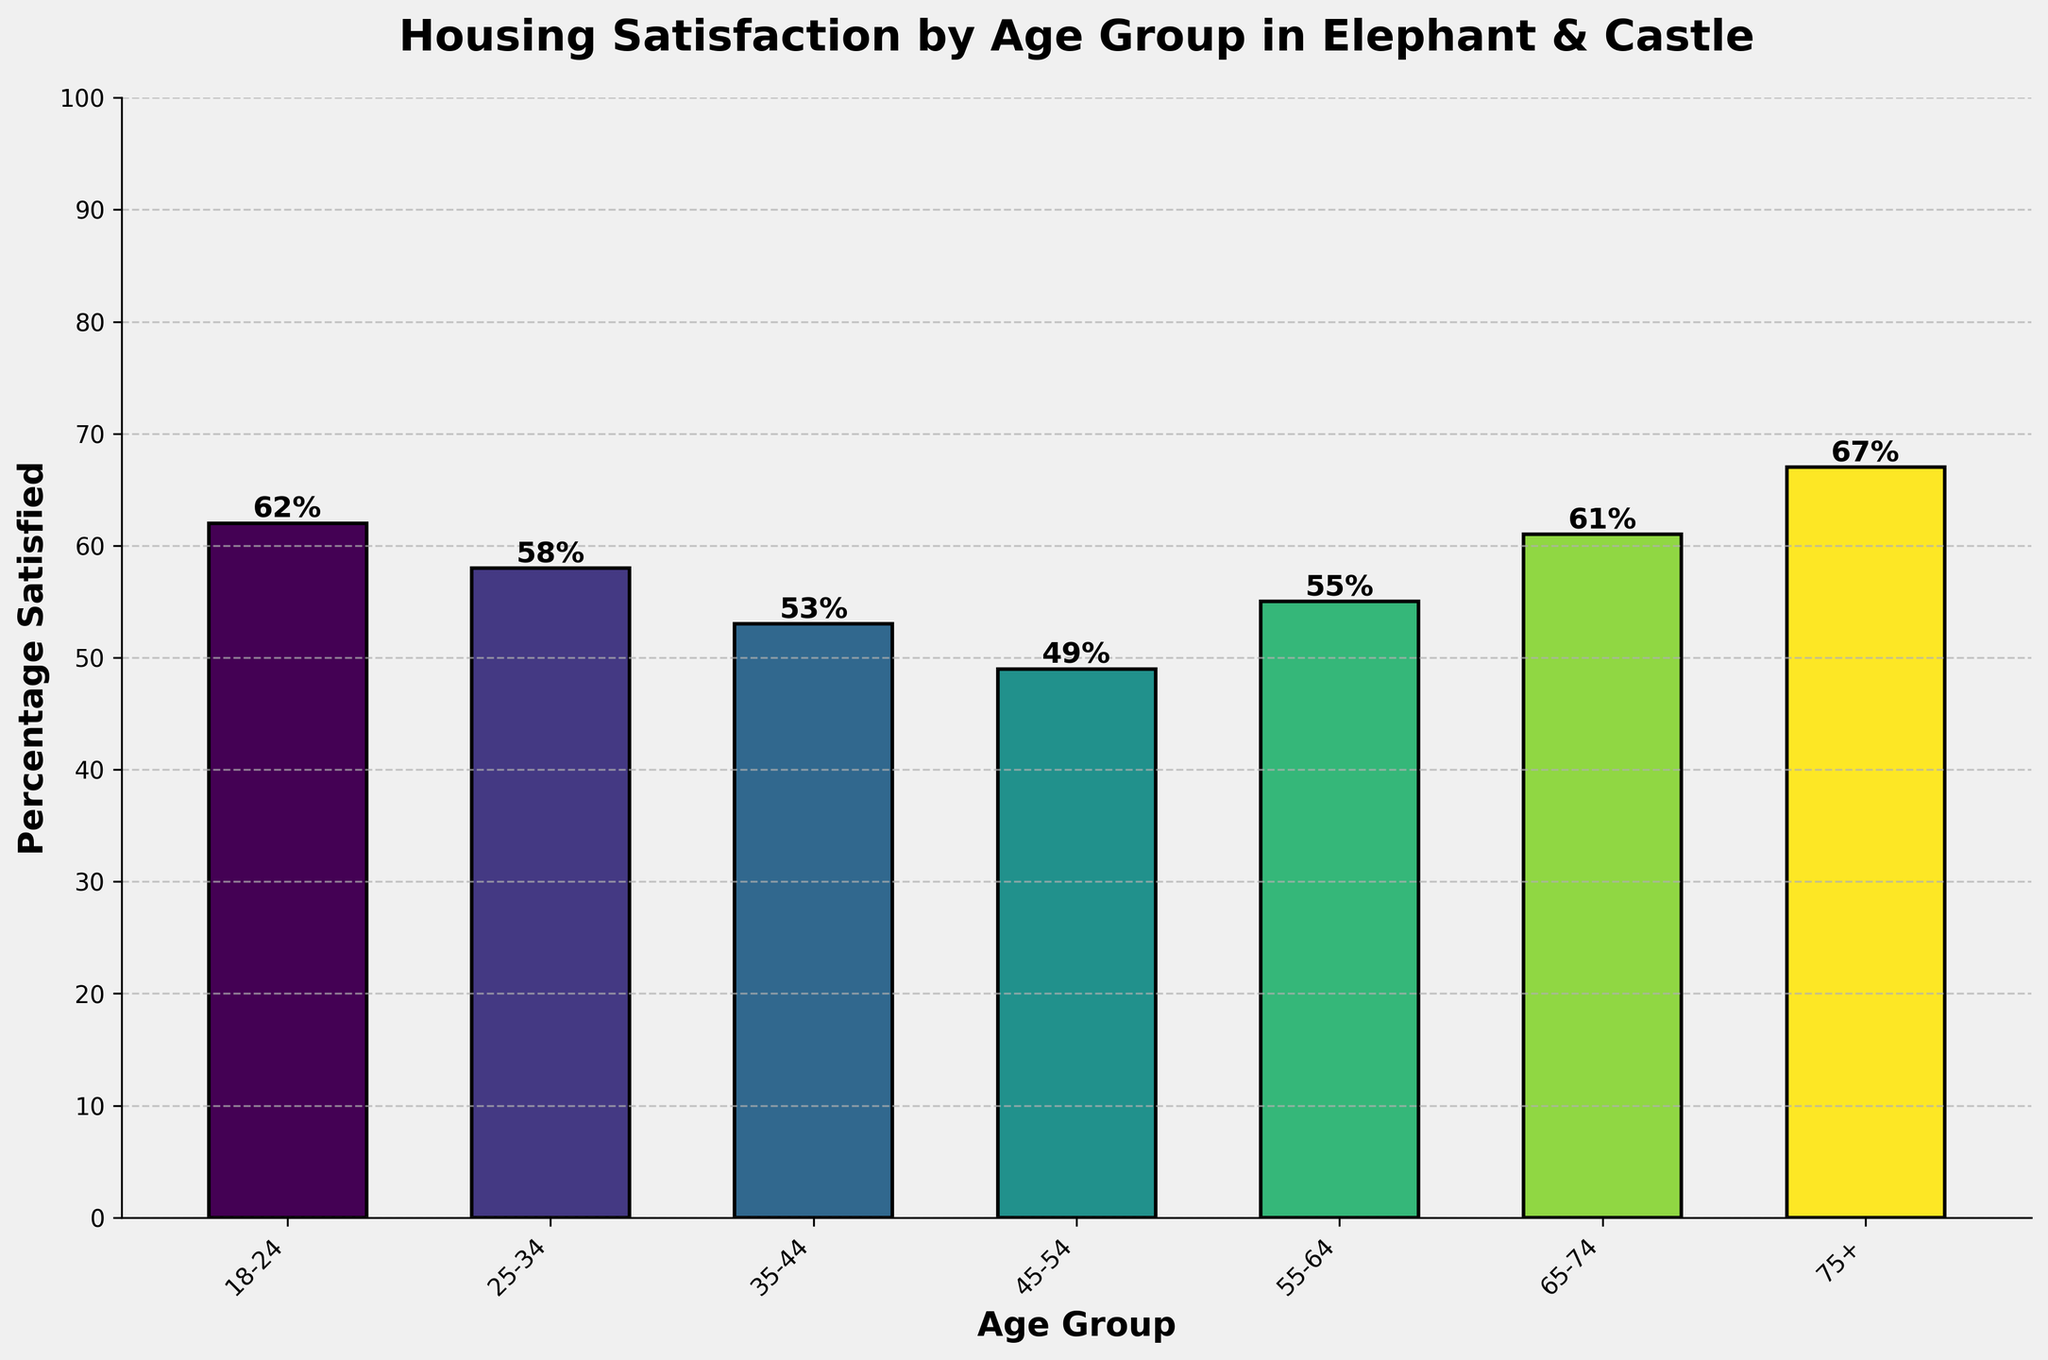Which age group has the highest percentage of residents satisfied with their housing conditions? The highest bar represents the age group with the highest percentage of residents satisfied. In this chart, the tallest bar is for the age group 75+.
Answer: 75+ Which age group has the lowest percentage of residents satisfied with their housing conditions? The shortest bar represents the age group with the lowest percentage of satisfaction. The bar for the age group 45-54 is the shortest.
Answer: 45-54 By how much does the satisfaction percentage of the 75+ age group exceed that of the 45-54 age group? Subtract the 45-54 percentage from the 75+ percentage. The difference is 67% - 49% = 18%.
Answer: 18% What is the average satisfaction percentage of all age groups? Add all the percentages and divide by the number of age groups: (62 + 58 + 53 + 49 + 55 + 61 + 67) / 7. The sum is 405, and the average is 405 / 7 = 57.86%.
Answer: 57.86% Which age groups have a higher satisfaction percentage than the average satisfaction percentage? Calculate the average satisfaction percentage as 57.86%. Compare each age group’s percentage to this average. The age groups 18-24, 65-74, and 75+ have values greater than the average.
Answer: 18-24, 65-74, 75+ How many age groups have over 60% satisfaction with their housing conditions? Identify the bars that exceed the 60% mark. The age groups 18-24, 65-74, and 75+ each exceed 60%, making 3 groups in total.
Answer: 3 Which age group shows a satisfaction percentage closest to 50%? The closest percentage to 50% is identified by comparing each to 50%. The age group 45-54 has 49%, which is closest to 50%.
Answer: 45-54 What is the difference in satisfaction percentage between the youngest (18-24) and the oldest (75+) age groups? Subtract the 18-24 percentage from the 75+ percentage. The difference is 67% - 62% = 5%.
Answer: 5% Do the age groups 25-34 and 35-44 combined have a higher satisfaction percentage than the age group 75+? Add the percentages of 25-34 and 35-44, then compare to the 75+ group. (58 + 53) = 111%, which is greater than 67%.
Answer: Yes 